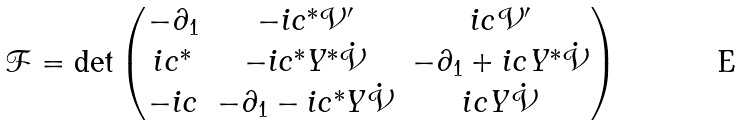Convert formula to latex. <formula><loc_0><loc_0><loc_500><loc_500>\mathcal { F } = \det \begin{pmatrix} - \partial _ { 1 } & - i c ^ { \ast } \mathcal { V } ^ { \prime } & i c \mathcal { V } ^ { \prime } \\ i c ^ { \ast } & - i c ^ { \ast } Y ^ { \ast } \dot { \mathcal { V } } & - \partial _ { 1 } + i c Y ^ { \ast } \dot { \mathcal { V } } \\ - i c & - \partial _ { 1 } - i c ^ { \ast } Y \dot { \mathcal { V } } & i c Y \dot { \mathcal { V } } \end{pmatrix}</formula> 